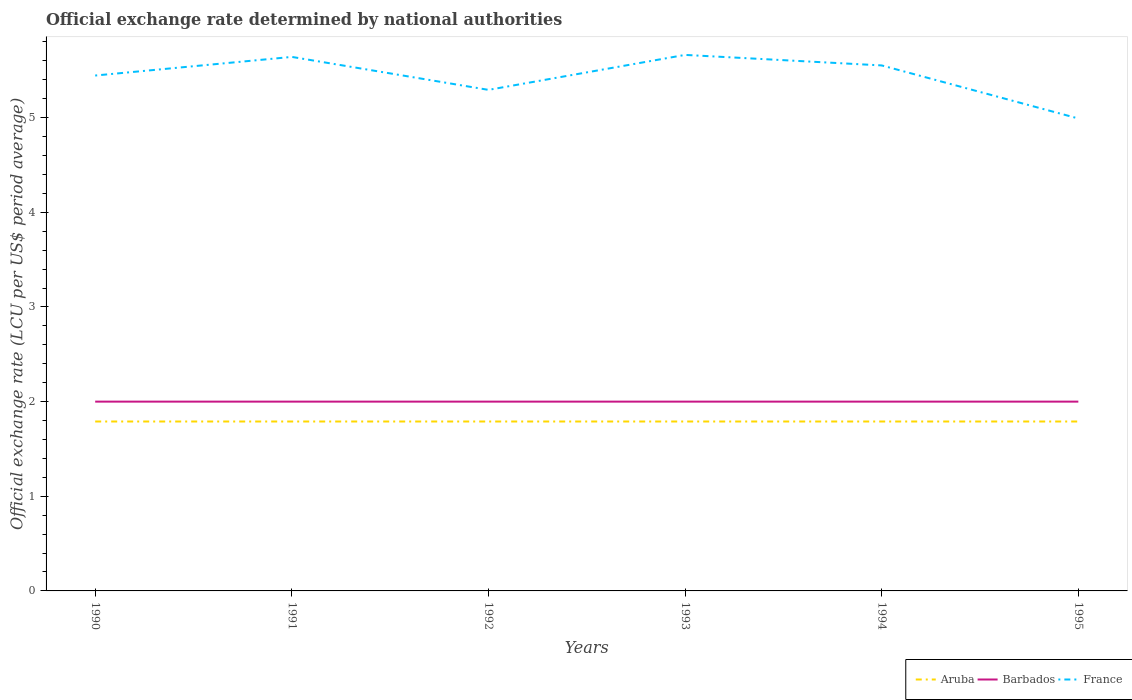Does the line corresponding to Aruba intersect with the line corresponding to France?
Your response must be concise. No. Is the number of lines equal to the number of legend labels?
Your answer should be very brief. Yes. Across all years, what is the maximum official exchange rate in France?
Ensure brevity in your answer.  4.99. In which year was the official exchange rate in France maximum?
Your response must be concise. 1995. What is the total official exchange rate in France in the graph?
Keep it short and to the point. -0.22. What is the difference between the highest and the lowest official exchange rate in Barbados?
Your answer should be compact. 0. How many years are there in the graph?
Provide a short and direct response. 6. Are the values on the major ticks of Y-axis written in scientific E-notation?
Provide a succinct answer. No. Does the graph contain any zero values?
Offer a terse response. No. Does the graph contain grids?
Offer a terse response. No. Where does the legend appear in the graph?
Keep it short and to the point. Bottom right. How are the legend labels stacked?
Your answer should be very brief. Horizontal. What is the title of the graph?
Ensure brevity in your answer.  Official exchange rate determined by national authorities. What is the label or title of the X-axis?
Offer a very short reply. Years. What is the label or title of the Y-axis?
Give a very brief answer. Official exchange rate (LCU per US$ period average). What is the Official exchange rate (LCU per US$ period average) of Aruba in 1990?
Your response must be concise. 1.79. What is the Official exchange rate (LCU per US$ period average) in France in 1990?
Your response must be concise. 5.45. What is the Official exchange rate (LCU per US$ period average) of Aruba in 1991?
Provide a short and direct response. 1.79. What is the Official exchange rate (LCU per US$ period average) of France in 1991?
Your answer should be very brief. 5.64. What is the Official exchange rate (LCU per US$ period average) of Aruba in 1992?
Your answer should be compact. 1.79. What is the Official exchange rate (LCU per US$ period average) of Barbados in 1992?
Provide a short and direct response. 2. What is the Official exchange rate (LCU per US$ period average) in France in 1992?
Your response must be concise. 5.29. What is the Official exchange rate (LCU per US$ period average) of Aruba in 1993?
Your answer should be compact. 1.79. What is the Official exchange rate (LCU per US$ period average) of France in 1993?
Your answer should be compact. 5.66. What is the Official exchange rate (LCU per US$ period average) of Aruba in 1994?
Provide a short and direct response. 1.79. What is the Official exchange rate (LCU per US$ period average) of France in 1994?
Ensure brevity in your answer.  5.55. What is the Official exchange rate (LCU per US$ period average) in Aruba in 1995?
Your answer should be compact. 1.79. What is the Official exchange rate (LCU per US$ period average) of France in 1995?
Ensure brevity in your answer.  4.99. Across all years, what is the maximum Official exchange rate (LCU per US$ period average) in Aruba?
Your response must be concise. 1.79. Across all years, what is the maximum Official exchange rate (LCU per US$ period average) of Barbados?
Your answer should be compact. 2. Across all years, what is the maximum Official exchange rate (LCU per US$ period average) in France?
Ensure brevity in your answer.  5.66. Across all years, what is the minimum Official exchange rate (LCU per US$ period average) in Aruba?
Make the answer very short. 1.79. Across all years, what is the minimum Official exchange rate (LCU per US$ period average) in Barbados?
Offer a terse response. 2. Across all years, what is the minimum Official exchange rate (LCU per US$ period average) of France?
Offer a very short reply. 4.99. What is the total Official exchange rate (LCU per US$ period average) of Aruba in the graph?
Make the answer very short. 10.74. What is the total Official exchange rate (LCU per US$ period average) of France in the graph?
Your response must be concise. 32.59. What is the difference between the Official exchange rate (LCU per US$ period average) in France in 1990 and that in 1991?
Your answer should be compact. -0.2. What is the difference between the Official exchange rate (LCU per US$ period average) of Aruba in 1990 and that in 1992?
Offer a very short reply. 0. What is the difference between the Official exchange rate (LCU per US$ period average) in Barbados in 1990 and that in 1992?
Your answer should be compact. 0. What is the difference between the Official exchange rate (LCU per US$ period average) of France in 1990 and that in 1992?
Your answer should be compact. 0.15. What is the difference between the Official exchange rate (LCU per US$ period average) of Barbados in 1990 and that in 1993?
Ensure brevity in your answer.  0. What is the difference between the Official exchange rate (LCU per US$ period average) of France in 1990 and that in 1993?
Your response must be concise. -0.22. What is the difference between the Official exchange rate (LCU per US$ period average) in Barbados in 1990 and that in 1994?
Offer a terse response. 0. What is the difference between the Official exchange rate (LCU per US$ period average) in France in 1990 and that in 1994?
Make the answer very short. -0.11. What is the difference between the Official exchange rate (LCU per US$ period average) in Aruba in 1990 and that in 1995?
Offer a very short reply. 0. What is the difference between the Official exchange rate (LCU per US$ period average) in France in 1990 and that in 1995?
Offer a terse response. 0.45. What is the difference between the Official exchange rate (LCU per US$ period average) in Aruba in 1991 and that in 1992?
Give a very brief answer. 0. What is the difference between the Official exchange rate (LCU per US$ period average) of Barbados in 1991 and that in 1992?
Ensure brevity in your answer.  0. What is the difference between the Official exchange rate (LCU per US$ period average) in France in 1991 and that in 1992?
Make the answer very short. 0.35. What is the difference between the Official exchange rate (LCU per US$ period average) of Aruba in 1991 and that in 1993?
Make the answer very short. 0. What is the difference between the Official exchange rate (LCU per US$ period average) in France in 1991 and that in 1993?
Keep it short and to the point. -0.02. What is the difference between the Official exchange rate (LCU per US$ period average) of Aruba in 1991 and that in 1994?
Keep it short and to the point. 0. What is the difference between the Official exchange rate (LCU per US$ period average) of Barbados in 1991 and that in 1994?
Provide a short and direct response. 0. What is the difference between the Official exchange rate (LCU per US$ period average) of France in 1991 and that in 1994?
Offer a terse response. 0.09. What is the difference between the Official exchange rate (LCU per US$ period average) in Aruba in 1991 and that in 1995?
Offer a very short reply. 0. What is the difference between the Official exchange rate (LCU per US$ period average) of Barbados in 1991 and that in 1995?
Ensure brevity in your answer.  0. What is the difference between the Official exchange rate (LCU per US$ period average) in France in 1991 and that in 1995?
Provide a short and direct response. 0.65. What is the difference between the Official exchange rate (LCU per US$ period average) in France in 1992 and that in 1993?
Make the answer very short. -0.37. What is the difference between the Official exchange rate (LCU per US$ period average) of France in 1992 and that in 1994?
Your answer should be very brief. -0.26. What is the difference between the Official exchange rate (LCU per US$ period average) of Aruba in 1992 and that in 1995?
Ensure brevity in your answer.  0. What is the difference between the Official exchange rate (LCU per US$ period average) of France in 1992 and that in 1995?
Give a very brief answer. 0.3. What is the difference between the Official exchange rate (LCU per US$ period average) in France in 1993 and that in 1994?
Your answer should be compact. 0.11. What is the difference between the Official exchange rate (LCU per US$ period average) of Aruba in 1993 and that in 1995?
Your answer should be compact. 0. What is the difference between the Official exchange rate (LCU per US$ period average) of Barbados in 1993 and that in 1995?
Keep it short and to the point. 0. What is the difference between the Official exchange rate (LCU per US$ period average) in France in 1993 and that in 1995?
Your answer should be very brief. 0.67. What is the difference between the Official exchange rate (LCU per US$ period average) in Barbados in 1994 and that in 1995?
Your response must be concise. 0. What is the difference between the Official exchange rate (LCU per US$ period average) of France in 1994 and that in 1995?
Your answer should be compact. 0.56. What is the difference between the Official exchange rate (LCU per US$ period average) in Aruba in 1990 and the Official exchange rate (LCU per US$ period average) in Barbados in 1991?
Provide a succinct answer. -0.21. What is the difference between the Official exchange rate (LCU per US$ period average) of Aruba in 1990 and the Official exchange rate (LCU per US$ period average) of France in 1991?
Keep it short and to the point. -3.85. What is the difference between the Official exchange rate (LCU per US$ period average) in Barbados in 1990 and the Official exchange rate (LCU per US$ period average) in France in 1991?
Offer a very short reply. -3.64. What is the difference between the Official exchange rate (LCU per US$ period average) of Aruba in 1990 and the Official exchange rate (LCU per US$ period average) of Barbados in 1992?
Your answer should be compact. -0.21. What is the difference between the Official exchange rate (LCU per US$ period average) in Aruba in 1990 and the Official exchange rate (LCU per US$ period average) in France in 1992?
Provide a succinct answer. -3.5. What is the difference between the Official exchange rate (LCU per US$ period average) of Barbados in 1990 and the Official exchange rate (LCU per US$ period average) of France in 1992?
Give a very brief answer. -3.29. What is the difference between the Official exchange rate (LCU per US$ period average) in Aruba in 1990 and the Official exchange rate (LCU per US$ period average) in Barbados in 1993?
Your response must be concise. -0.21. What is the difference between the Official exchange rate (LCU per US$ period average) of Aruba in 1990 and the Official exchange rate (LCU per US$ period average) of France in 1993?
Offer a terse response. -3.87. What is the difference between the Official exchange rate (LCU per US$ period average) of Barbados in 1990 and the Official exchange rate (LCU per US$ period average) of France in 1993?
Ensure brevity in your answer.  -3.66. What is the difference between the Official exchange rate (LCU per US$ period average) of Aruba in 1990 and the Official exchange rate (LCU per US$ period average) of Barbados in 1994?
Provide a succinct answer. -0.21. What is the difference between the Official exchange rate (LCU per US$ period average) in Aruba in 1990 and the Official exchange rate (LCU per US$ period average) in France in 1994?
Make the answer very short. -3.76. What is the difference between the Official exchange rate (LCU per US$ period average) in Barbados in 1990 and the Official exchange rate (LCU per US$ period average) in France in 1994?
Keep it short and to the point. -3.55. What is the difference between the Official exchange rate (LCU per US$ period average) of Aruba in 1990 and the Official exchange rate (LCU per US$ period average) of Barbados in 1995?
Offer a terse response. -0.21. What is the difference between the Official exchange rate (LCU per US$ period average) of Aruba in 1990 and the Official exchange rate (LCU per US$ period average) of France in 1995?
Your answer should be compact. -3.2. What is the difference between the Official exchange rate (LCU per US$ period average) of Barbados in 1990 and the Official exchange rate (LCU per US$ period average) of France in 1995?
Offer a terse response. -2.99. What is the difference between the Official exchange rate (LCU per US$ period average) of Aruba in 1991 and the Official exchange rate (LCU per US$ period average) of Barbados in 1992?
Make the answer very short. -0.21. What is the difference between the Official exchange rate (LCU per US$ period average) of Aruba in 1991 and the Official exchange rate (LCU per US$ period average) of France in 1992?
Give a very brief answer. -3.5. What is the difference between the Official exchange rate (LCU per US$ period average) of Barbados in 1991 and the Official exchange rate (LCU per US$ period average) of France in 1992?
Provide a short and direct response. -3.29. What is the difference between the Official exchange rate (LCU per US$ period average) in Aruba in 1991 and the Official exchange rate (LCU per US$ period average) in Barbados in 1993?
Make the answer very short. -0.21. What is the difference between the Official exchange rate (LCU per US$ period average) of Aruba in 1991 and the Official exchange rate (LCU per US$ period average) of France in 1993?
Provide a short and direct response. -3.87. What is the difference between the Official exchange rate (LCU per US$ period average) of Barbados in 1991 and the Official exchange rate (LCU per US$ period average) of France in 1993?
Provide a succinct answer. -3.66. What is the difference between the Official exchange rate (LCU per US$ period average) of Aruba in 1991 and the Official exchange rate (LCU per US$ period average) of Barbados in 1994?
Provide a succinct answer. -0.21. What is the difference between the Official exchange rate (LCU per US$ period average) in Aruba in 1991 and the Official exchange rate (LCU per US$ period average) in France in 1994?
Your answer should be compact. -3.76. What is the difference between the Official exchange rate (LCU per US$ period average) of Barbados in 1991 and the Official exchange rate (LCU per US$ period average) of France in 1994?
Provide a succinct answer. -3.55. What is the difference between the Official exchange rate (LCU per US$ period average) in Aruba in 1991 and the Official exchange rate (LCU per US$ period average) in Barbados in 1995?
Make the answer very short. -0.21. What is the difference between the Official exchange rate (LCU per US$ period average) of Aruba in 1991 and the Official exchange rate (LCU per US$ period average) of France in 1995?
Your response must be concise. -3.2. What is the difference between the Official exchange rate (LCU per US$ period average) of Barbados in 1991 and the Official exchange rate (LCU per US$ period average) of France in 1995?
Keep it short and to the point. -2.99. What is the difference between the Official exchange rate (LCU per US$ period average) in Aruba in 1992 and the Official exchange rate (LCU per US$ period average) in Barbados in 1993?
Provide a short and direct response. -0.21. What is the difference between the Official exchange rate (LCU per US$ period average) of Aruba in 1992 and the Official exchange rate (LCU per US$ period average) of France in 1993?
Your response must be concise. -3.87. What is the difference between the Official exchange rate (LCU per US$ period average) in Barbados in 1992 and the Official exchange rate (LCU per US$ period average) in France in 1993?
Your answer should be compact. -3.66. What is the difference between the Official exchange rate (LCU per US$ period average) of Aruba in 1992 and the Official exchange rate (LCU per US$ period average) of Barbados in 1994?
Ensure brevity in your answer.  -0.21. What is the difference between the Official exchange rate (LCU per US$ period average) in Aruba in 1992 and the Official exchange rate (LCU per US$ period average) in France in 1994?
Provide a succinct answer. -3.76. What is the difference between the Official exchange rate (LCU per US$ period average) of Barbados in 1992 and the Official exchange rate (LCU per US$ period average) of France in 1994?
Keep it short and to the point. -3.55. What is the difference between the Official exchange rate (LCU per US$ period average) of Aruba in 1992 and the Official exchange rate (LCU per US$ period average) of Barbados in 1995?
Your answer should be compact. -0.21. What is the difference between the Official exchange rate (LCU per US$ period average) in Aruba in 1992 and the Official exchange rate (LCU per US$ period average) in France in 1995?
Offer a very short reply. -3.2. What is the difference between the Official exchange rate (LCU per US$ period average) of Barbados in 1992 and the Official exchange rate (LCU per US$ period average) of France in 1995?
Ensure brevity in your answer.  -2.99. What is the difference between the Official exchange rate (LCU per US$ period average) of Aruba in 1993 and the Official exchange rate (LCU per US$ period average) of Barbados in 1994?
Make the answer very short. -0.21. What is the difference between the Official exchange rate (LCU per US$ period average) of Aruba in 1993 and the Official exchange rate (LCU per US$ period average) of France in 1994?
Ensure brevity in your answer.  -3.76. What is the difference between the Official exchange rate (LCU per US$ period average) of Barbados in 1993 and the Official exchange rate (LCU per US$ period average) of France in 1994?
Offer a very short reply. -3.55. What is the difference between the Official exchange rate (LCU per US$ period average) in Aruba in 1993 and the Official exchange rate (LCU per US$ period average) in Barbados in 1995?
Offer a very short reply. -0.21. What is the difference between the Official exchange rate (LCU per US$ period average) in Aruba in 1993 and the Official exchange rate (LCU per US$ period average) in France in 1995?
Offer a terse response. -3.2. What is the difference between the Official exchange rate (LCU per US$ period average) in Barbados in 1993 and the Official exchange rate (LCU per US$ period average) in France in 1995?
Offer a terse response. -2.99. What is the difference between the Official exchange rate (LCU per US$ period average) in Aruba in 1994 and the Official exchange rate (LCU per US$ period average) in Barbados in 1995?
Give a very brief answer. -0.21. What is the difference between the Official exchange rate (LCU per US$ period average) of Aruba in 1994 and the Official exchange rate (LCU per US$ period average) of France in 1995?
Provide a succinct answer. -3.2. What is the difference between the Official exchange rate (LCU per US$ period average) in Barbados in 1994 and the Official exchange rate (LCU per US$ period average) in France in 1995?
Your answer should be compact. -2.99. What is the average Official exchange rate (LCU per US$ period average) of Aruba per year?
Your answer should be compact. 1.79. What is the average Official exchange rate (LCU per US$ period average) of France per year?
Give a very brief answer. 5.43. In the year 1990, what is the difference between the Official exchange rate (LCU per US$ period average) of Aruba and Official exchange rate (LCU per US$ period average) of Barbados?
Offer a very short reply. -0.21. In the year 1990, what is the difference between the Official exchange rate (LCU per US$ period average) of Aruba and Official exchange rate (LCU per US$ period average) of France?
Your answer should be very brief. -3.66. In the year 1990, what is the difference between the Official exchange rate (LCU per US$ period average) in Barbados and Official exchange rate (LCU per US$ period average) in France?
Keep it short and to the point. -3.45. In the year 1991, what is the difference between the Official exchange rate (LCU per US$ period average) in Aruba and Official exchange rate (LCU per US$ period average) in Barbados?
Give a very brief answer. -0.21. In the year 1991, what is the difference between the Official exchange rate (LCU per US$ period average) of Aruba and Official exchange rate (LCU per US$ period average) of France?
Offer a very short reply. -3.85. In the year 1991, what is the difference between the Official exchange rate (LCU per US$ period average) of Barbados and Official exchange rate (LCU per US$ period average) of France?
Your answer should be compact. -3.64. In the year 1992, what is the difference between the Official exchange rate (LCU per US$ period average) of Aruba and Official exchange rate (LCU per US$ period average) of Barbados?
Offer a terse response. -0.21. In the year 1992, what is the difference between the Official exchange rate (LCU per US$ period average) in Aruba and Official exchange rate (LCU per US$ period average) in France?
Your response must be concise. -3.5. In the year 1992, what is the difference between the Official exchange rate (LCU per US$ period average) of Barbados and Official exchange rate (LCU per US$ period average) of France?
Your answer should be very brief. -3.29. In the year 1993, what is the difference between the Official exchange rate (LCU per US$ period average) in Aruba and Official exchange rate (LCU per US$ period average) in Barbados?
Give a very brief answer. -0.21. In the year 1993, what is the difference between the Official exchange rate (LCU per US$ period average) in Aruba and Official exchange rate (LCU per US$ period average) in France?
Offer a very short reply. -3.87. In the year 1993, what is the difference between the Official exchange rate (LCU per US$ period average) of Barbados and Official exchange rate (LCU per US$ period average) of France?
Provide a short and direct response. -3.66. In the year 1994, what is the difference between the Official exchange rate (LCU per US$ period average) of Aruba and Official exchange rate (LCU per US$ period average) of Barbados?
Ensure brevity in your answer.  -0.21. In the year 1994, what is the difference between the Official exchange rate (LCU per US$ period average) in Aruba and Official exchange rate (LCU per US$ period average) in France?
Provide a succinct answer. -3.76. In the year 1994, what is the difference between the Official exchange rate (LCU per US$ period average) of Barbados and Official exchange rate (LCU per US$ period average) of France?
Your answer should be very brief. -3.55. In the year 1995, what is the difference between the Official exchange rate (LCU per US$ period average) of Aruba and Official exchange rate (LCU per US$ period average) of Barbados?
Your answer should be compact. -0.21. In the year 1995, what is the difference between the Official exchange rate (LCU per US$ period average) in Aruba and Official exchange rate (LCU per US$ period average) in France?
Make the answer very short. -3.2. In the year 1995, what is the difference between the Official exchange rate (LCU per US$ period average) in Barbados and Official exchange rate (LCU per US$ period average) in France?
Make the answer very short. -2.99. What is the ratio of the Official exchange rate (LCU per US$ period average) in Aruba in 1990 to that in 1991?
Provide a short and direct response. 1. What is the ratio of the Official exchange rate (LCU per US$ period average) of Barbados in 1990 to that in 1991?
Ensure brevity in your answer.  1. What is the ratio of the Official exchange rate (LCU per US$ period average) in France in 1990 to that in 1991?
Your answer should be compact. 0.97. What is the ratio of the Official exchange rate (LCU per US$ period average) of France in 1990 to that in 1992?
Offer a terse response. 1.03. What is the ratio of the Official exchange rate (LCU per US$ period average) of Aruba in 1990 to that in 1993?
Your answer should be very brief. 1. What is the ratio of the Official exchange rate (LCU per US$ period average) of France in 1990 to that in 1993?
Make the answer very short. 0.96. What is the ratio of the Official exchange rate (LCU per US$ period average) of France in 1990 to that in 1994?
Ensure brevity in your answer.  0.98. What is the ratio of the Official exchange rate (LCU per US$ period average) in Barbados in 1990 to that in 1995?
Provide a short and direct response. 1. What is the ratio of the Official exchange rate (LCU per US$ period average) in Aruba in 1991 to that in 1992?
Keep it short and to the point. 1. What is the ratio of the Official exchange rate (LCU per US$ period average) of Barbados in 1991 to that in 1992?
Your response must be concise. 1. What is the ratio of the Official exchange rate (LCU per US$ period average) in France in 1991 to that in 1992?
Keep it short and to the point. 1.07. What is the ratio of the Official exchange rate (LCU per US$ period average) of France in 1991 to that in 1993?
Give a very brief answer. 1. What is the ratio of the Official exchange rate (LCU per US$ period average) of Aruba in 1991 to that in 1994?
Ensure brevity in your answer.  1. What is the ratio of the Official exchange rate (LCU per US$ period average) of Barbados in 1991 to that in 1994?
Ensure brevity in your answer.  1. What is the ratio of the Official exchange rate (LCU per US$ period average) in France in 1991 to that in 1994?
Make the answer very short. 1.02. What is the ratio of the Official exchange rate (LCU per US$ period average) of France in 1991 to that in 1995?
Make the answer very short. 1.13. What is the ratio of the Official exchange rate (LCU per US$ period average) in Aruba in 1992 to that in 1993?
Offer a terse response. 1. What is the ratio of the Official exchange rate (LCU per US$ period average) in Barbados in 1992 to that in 1993?
Ensure brevity in your answer.  1. What is the ratio of the Official exchange rate (LCU per US$ period average) in France in 1992 to that in 1993?
Offer a terse response. 0.93. What is the ratio of the Official exchange rate (LCU per US$ period average) in Aruba in 1992 to that in 1994?
Offer a terse response. 1. What is the ratio of the Official exchange rate (LCU per US$ period average) in Barbados in 1992 to that in 1994?
Keep it short and to the point. 1. What is the ratio of the Official exchange rate (LCU per US$ period average) in France in 1992 to that in 1994?
Ensure brevity in your answer.  0.95. What is the ratio of the Official exchange rate (LCU per US$ period average) in France in 1992 to that in 1995?
Keep it short and to the point. 1.06. What is the ratio of the Official exchange rate (LCU per US$ period average) in Aruba in 1993 to that in 1994?
Give a very brief answer. 1. What is the ratio of the Official exchange rate (LCU per US$ period average) in Barbados in 1993 to that in 1994?
Your answer should be very brief. 1. What is the ratio of the Official exchange rate (LCU per US$ period average) of Aruba in 1993 to that in 1995?
Keep it short and to the point. 1. What is the ratio of the Official exchange rate (LCU per US$ period average) of Barbados in 1993 to that in 1995?
Keep it short and to the point. 1. What is the ratio of the Official exchange rate (LCU per US$ period average) of France in 1993 to that in 1995?
Provide a short and direct response. 1.13. What is the ratio of the Official exchange rate (LCU per US$ period average) in France in 1994 to that in 1995?
Provide a succinct answer. 1.11. What is the difference between the highest and the second highest Official exchange rate (LCU per US$ period average) in Aruba?
Keep it short and to the point. 0. What is the difference between the highest and the second highest Official exchange rate (LCU per US$ period average) in France?
Keep it short and to the point. 0.02. What is the difference between the highest and the lowest Official exchange rate (LCU per US$ period average) of Aruba?
Provide a succinct answer. 0. What is the difference between the highest and the lowest Official exchange rate (LCU per US$ period average) of Barbados?
Your answer should be compact. 0. What is the difference between the highest and the lowest Official exchange rate (LCU per US$ period average) of France?
Provide a succinct answer. 0.67. 